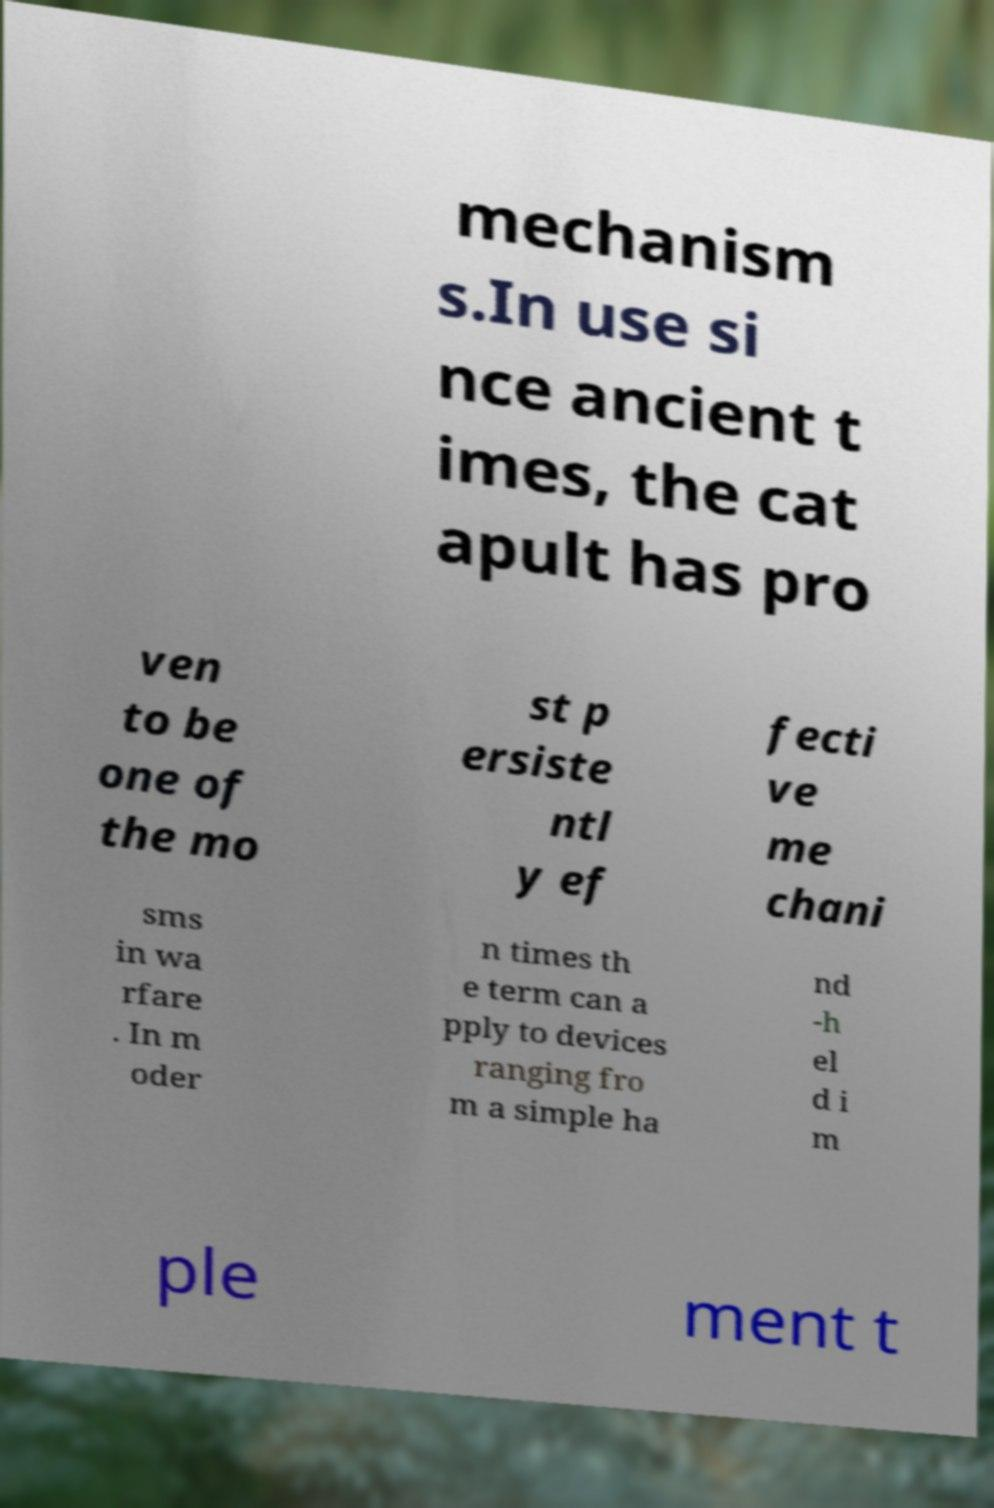I need the written content from this picture converted into text. Can you do that? mechanism s.In use si nce ancient t imes, the cat apult has pro ven to be one of the mo st p ersiste ntl y ef fecti ve me chani sms in wa rfare . In m oder n times th e term can a pply to devices ranging fro m a simple ha nd -h el d i m ple ment t 